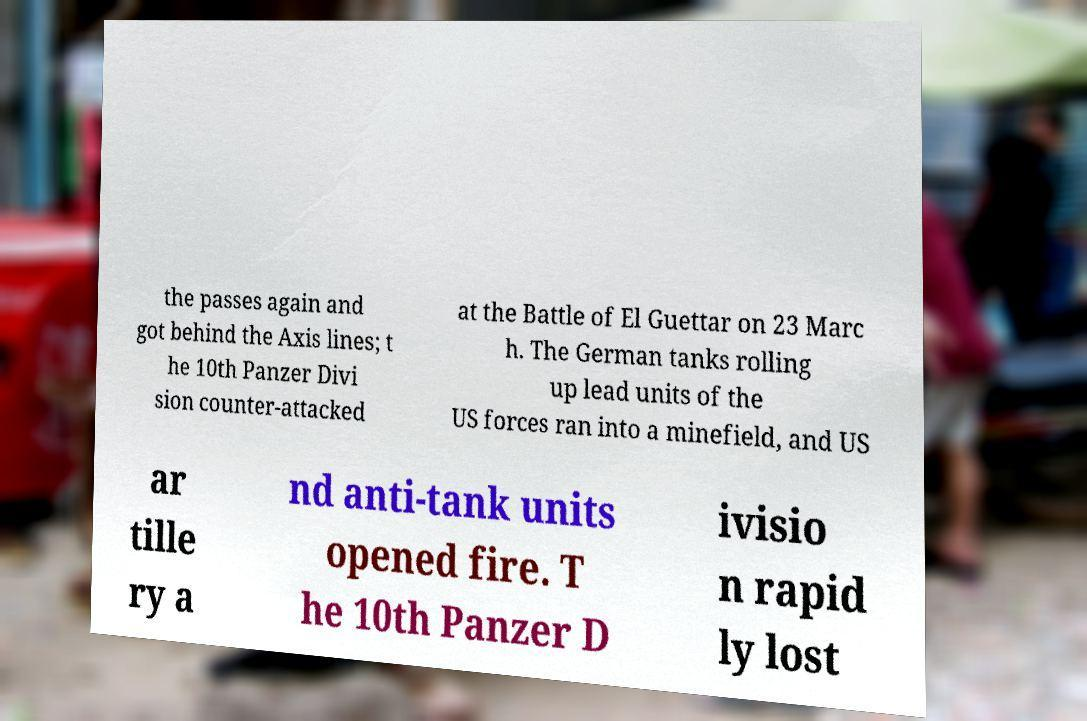Could you extract and type out the text from this image? the passes again and got behind the Axis lines; t he 10th Panzer Divi sion counter-attacked at the Battle of El Guettar on 23 Marc h. The German tanks rolling up lead units of the US forces ran into a minefield, and US ar tille ry a nd anti-tank units opened fire. T he 10th Panzer D ivisio n rapid ly lost 